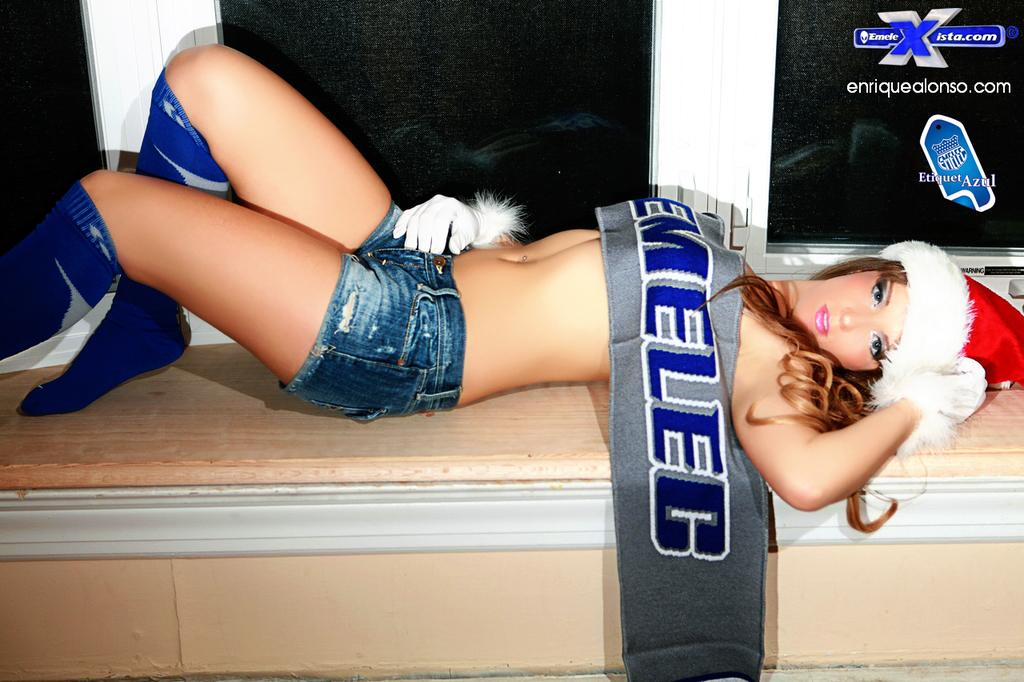<image>
Render a clear and concise summary of the photo. A girl has a scarf that says "EMELEC" across her chest. 